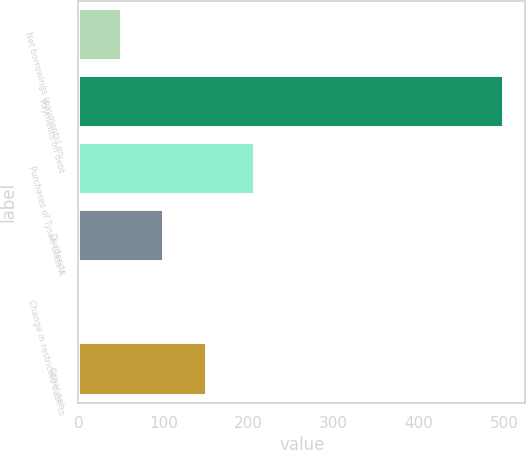Convert chart. <chart><loc_0><loc_0><loc_500><loc_500><bar_chart><fcel>Net borrowings (payments) on<fcel>Payments on debt<fcel>Purchases of Tyson Class A<fcel>Dividends<fcel>Change in restricted cash to<fcel>Other net<nl><fcel>51.03<fcel>500<fcel>207<fcel>100.92<fcel>1.14<fcel>150.81<nl></chart> 